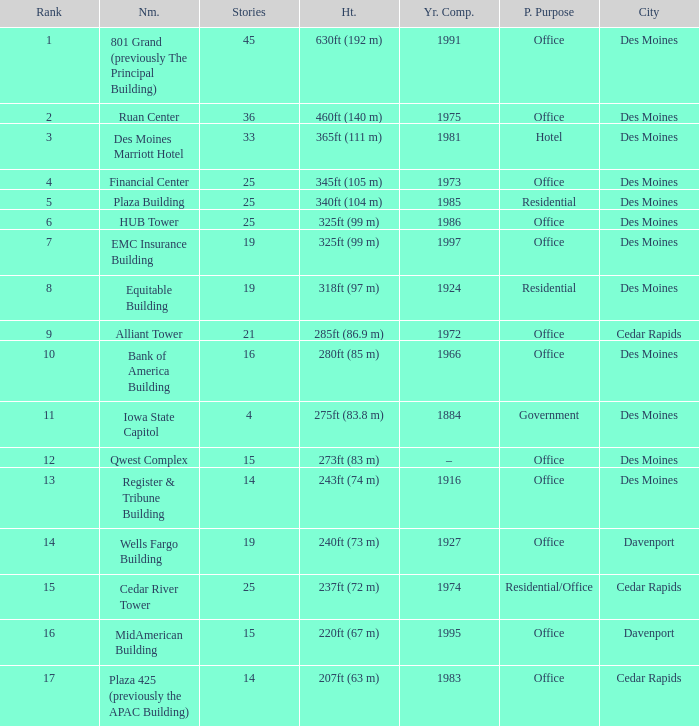What is the total stories that rank number 10? 1.0. 